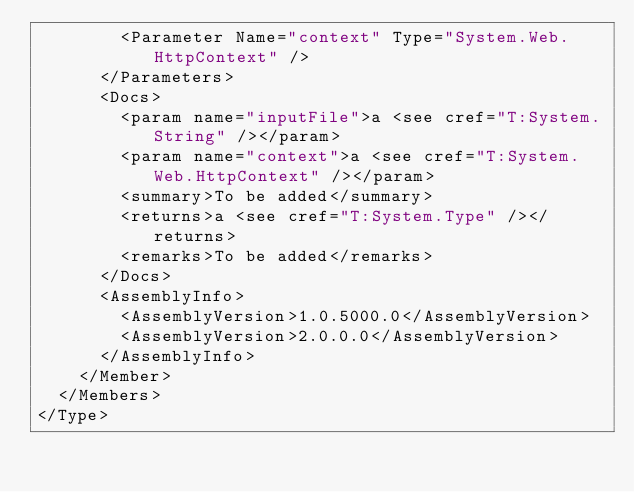Convert code to text. <code><loc_0><loc_0><loc_500><loc_500><_XML_>        <Parameter Name="context" Type="System.Web.HttpContext" />
      </Parameters>
      <Docs>
        <param name="inputFile">a <see cref="T:System.String" /></param>
        <param name="context">a <see cref="T:System.Web.HttpContext" /></param>
        <summary>To be added</summary>
        <returns>a <see cref="T:System.Type" /></returns>
        <remarks>To be added</remarks>
      </Docs>
      <AssemblyInfo>
        <AssemblyVersion>1.0.5000.0</AssemblyVersion>
        <AssemblyVersion>2.0.0.0</AssemblyVersion>
      </AssemblyInfo>
    </Member>
  </Members>
</Type>
</code> 